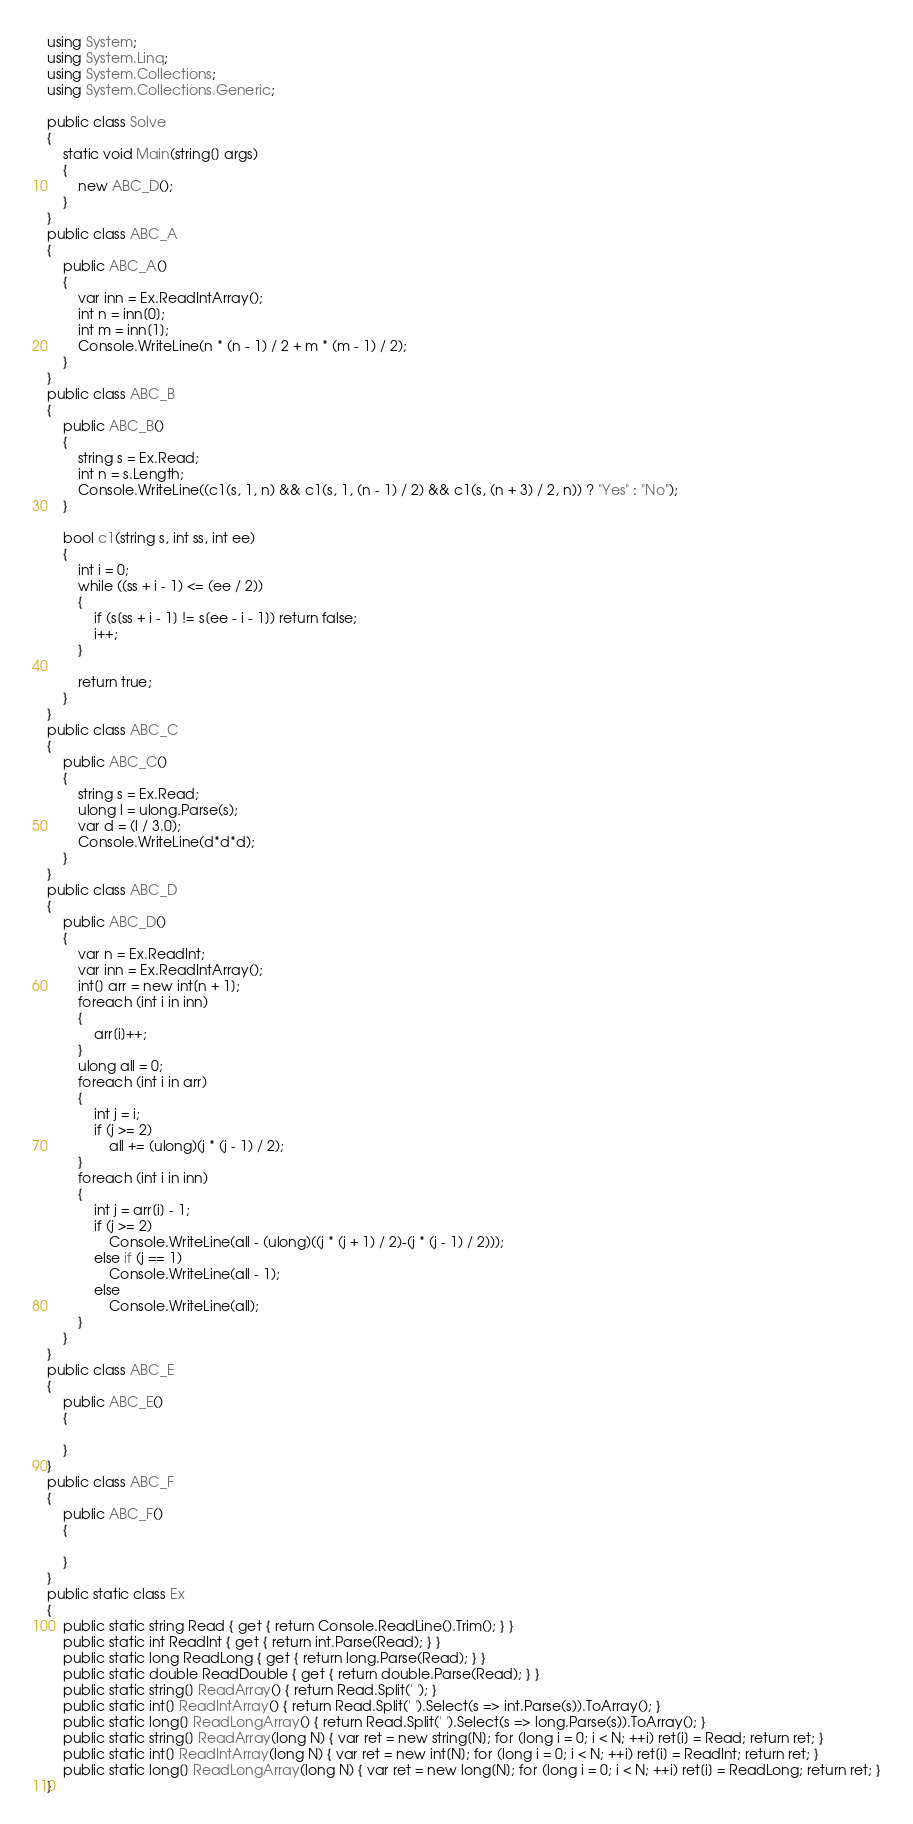Convert code to text. <code><loc_0><loc_0><loc_500><loc_500><_C#_>using System;
using System.Linq;
using System.Collections;
using System.Collections.Generic;

public class Solve
{
    static void Main(string[] args)
    {
        new ABC_D();
    }
}
public class ABC_A
{
    public ABC_A()
    {
        var inn = Ex.ReadIntArray();
        int n = inn[0];
        int m = inn[1];
        Console.WriteLine(n * (n - 1) / 2 + m * (m - 1) / 2);
    }
}
public class ABC_B
{
    public ABC_B()
    {
        string s = Ex.Read;
        int n = s.Length;
        Console.WriteLine((c1(s, 1, n) && c1(s, 1, (n - 1) / 2) && c1(s, (n + 3) / 2, n)) ? "Yes" : "No");
    }

    bool c1(string s, int ss, int ee)
    {
        int i = 0;
        while ((ss + i - 1) <= (ee / 2))
        {
            if (s[ss + i - 1] != s[ee - i - 1]) return false;
            i++;
        }

        return true;
    }
}
public class ABC_C
{
    public ABC_C()
    {
        string s = Ex.Read;
        ulong l = ulong.Parse(s);
        var d = (l / 3.0);
        Console.WriteLine(d*d*d);
    }
}
public class ABC_D
{
    public ABC_D()
    {
        var n = Ex.ReadInt;
        var inn = Ex.ReadIntArray();
        int[] arr = new int[n + 1];
        foreach (int i in inn)
        {
            arr[i]++;
        }
        ulong all = 0;
        foreach (int i in arr)
        {
            int j = i;
            if (j >= 2)
                all += (ulong)(j * (j - 1) / 2);
        }
        foreach (int i in inn)
        {
            int j = arr[i] - 1;
            if (j >= 2)
                Console.WriteLine(all - (ulong)((j * (j + 1) / 2)-(j * (j - 1) / 2)));
            else if (j == 1)
                Console.WriteLine(all - 1);
            else
                Console.WriteLine(all);
        }
    }
}
public class ABC_E
{
    public ABC_E()
    {

    }
}
public class ABC_F
{
    public ABC_F()
    {

    }
}
public static class Ex
{
    public static string Read { get { return Console.ReadLine().Trim(); } }
    public static int ReadInt { get { return int.Parse(Read); } }
    public static long ReadLong { get { return long.Parse(Read); } }
    public static double ReadDouble { get { return double.Parse(Read); } }
    public static string[] ReadArray() { return Read.Split(' '); }
    public static int[] ReadIntArray() { return Read.Split(' ').Select(s => int.Parse(s)).ToArray(); }
    public static long[] ReadLongArray() { return Read.Split(' ').Select(s => long.Parse(s)).ToArray(); }
    public static string[] ReadArray(long N) { var ret = new string[N]; for (long i = 0; i < N; ++i) ret[i] = Read; return ret; }
    public static int[] ReadIntArray(long N) { var ret = new int[N]; for (long i = 0; i < N; ++i) ret[i] = ReadInt; return ret; }
    public static long[] ReadLongArray(long N) { var ret = new long[N]; for (long i = 0; i < N; ++i) ret[i] = ReadLong; return ret; }
}</code> 